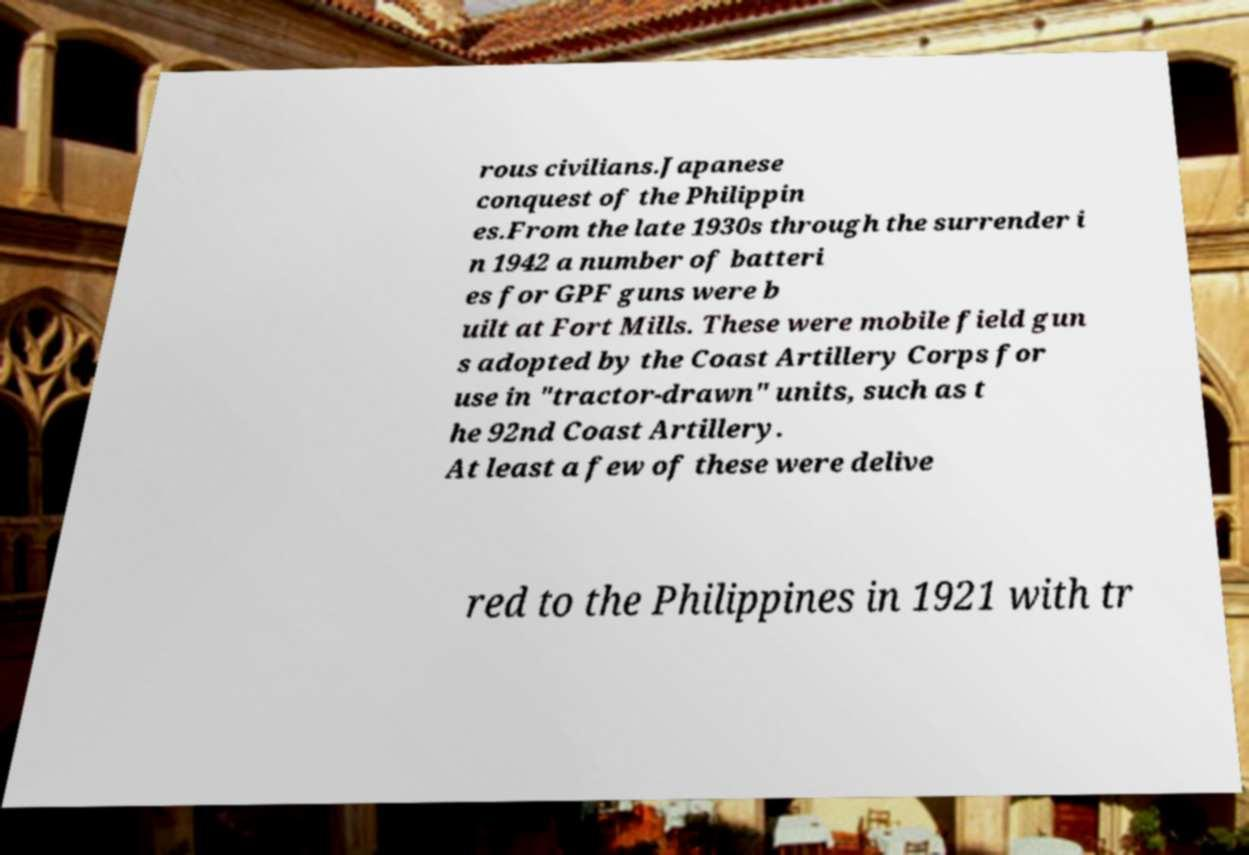Can you read and provide the text displayed in the image?This photo seems to have some interesting text. Can you extract and type it out for me? rous civilians.Japanese conquest of the Philippin es.From the late 1930s through the surrender i n 1942 a number of batteri es for GPF guns were b uilt at Fort Mills. These were mobile field gun s adopted by the Coast Artillery Corps for use in "tractor-drawn" units, such as t he 92nd Coast Artillery. At least a few of these were delive red to the Philippines in 1921 with tr 